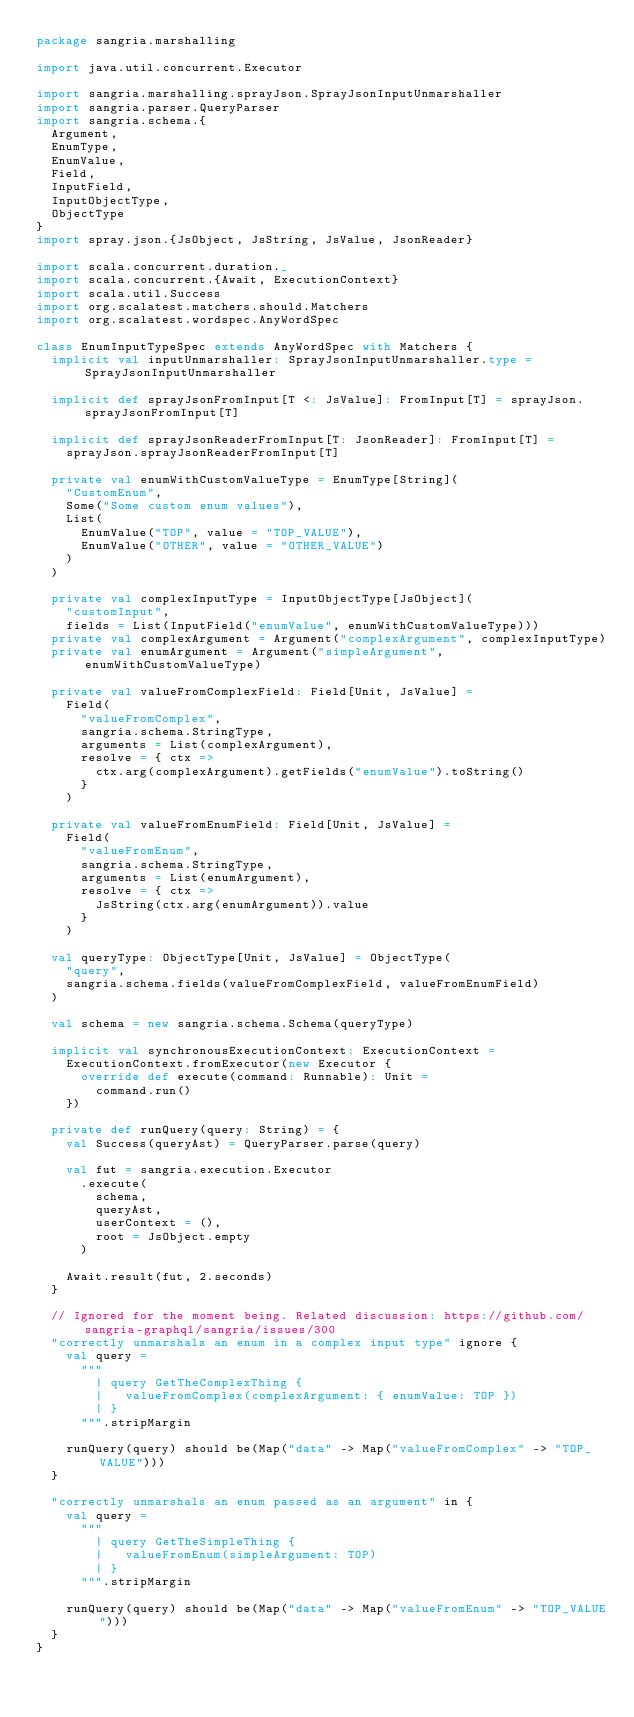<code> <loc_0><loc_0><loc_500><loc_500><_Scala_>package sangria.marshalling

import java.util.concurrent.Executor

import sangria.marshalling.sprayJson.SprayJsonInputUnmarshaller
import sangria.parser.QueryParser
import sangria.schema.{
  Argument,
  EnumType,
  EnumValue,
  Field,
  InputField,
  InputObjectType,
  ObjectType
}
import spray.json.{JsObject, JsString, JsValue, JsonReader}

import scala.concurrent.duration._
import scala.concurrent.{Await, ExecutionContext}
import scala.util.Success
import org.scalatest.matchers.should.Matchers
import org.scalatest.wordspec.AnyWordSpec

class EnumInputTypeSpec extends AnyWordSpec with Matchers {
  implicit val inputUnmarshaller: SprayJsonInputUnmarshaller.type = SprayJsonInputUnmarshaller

  implicit def sprayJsonFromInput[T <: JsValue]: FromInput[T] = sprayJson.sprayJsonFromInput[T]

  implicit def sprayJsonReaderFromInput[T: JsonReader]: FromInput[T] =
    sprayJson.sprayJsonReaderFromInput[T]

  private val enumWithCustomValueType = EnumType[String](
    "CustomEnum",
    Some("Some custom enum values"),
    List(
      EnumValue("TOP", value = "TOP_VALUE"),
      EnumValue("OTHER", value = "OTHER_VALUE")
    )
  )

  private val complexInputType = InputObjectType[JsObject](
    "customInput",
    fields = List(InputField("enumValue", enumWithCustomValueType)))
  private val complexArgument = Argument("complexArgument", complexInputType)
  private val enumArgument = Argument("simpleArgument", enumWithCustomValueType)

  private val valueFromComplexField: Field[Unit, JsValue] =
    Field(
      "valueFromComplex",
      sangria.schema.StringType,
      arguments = List(complexArgument),
      resolve = { ctx =>
        ctx.arg(complexArgument).getFields("enumValue").toString()
      }
    )

  private val valueFromEnumField: Field[Unit, JsValue] =
    Field(
      "valueFromEnum",
      sangria.schema.StringType,
      arguments = List(enumArgument),
      resolve = { ctx =>
        JsString(ctx.arg(enumArgument)).value
      }
    )

  val queryType: ObjectType[Unit, JsValue] = ObjectType(
    "query",
    sangria.schema.fields(valueFromComplexField, valueFromEnumField)
  )

  val schema = new sangria.schema.Schema(queryType)

  implicit val synchronousExecutionContext: ExecutionContext =
    ExecutionContext.fromExecutor(new Executor {
      override def execute(command: Runnable): Unit =
        command.run()
    })

  private def runQuery(query: String) = {
    val Success(queryAst) = QueryParser.parse(query)

    val fut = sangria.execution.Executor
      .execute(
        schema,
        queryAst,
        userContext = (),
        root = JsObject.empty
      )

    Await.result(fut, 2.seconds)
  }

  // Ignored for the moment being. Related discussion: https://github.com/sangria-graphql/sangria/issues/300
  "correctly unmarshals an enum in a complex input type" ignore {
    val query =
      """
        | query GetTheComplexThing {
        |   valueFromComplex(complexArgument: { enumValue: TOP })
        | }
      """.stripMargin

    runQuery(query) should be(Map("data" -> Map("valueFromComplex" -> "TOP_VALUE")))
  }

  "correctly unmarshals an enum passed as an argument" in {
    val query =
      """
        | query GetTheSimpleThing {
        |   valueFromEnum(simpleArgument: TOP)
        | }
      """.stripMargin

    runQuery(query) should be(Map("data" -> Map("valueFromEnum" -> "TOP_VALUE")))
  }
}
</code> 